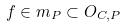Convert formula to latex. <formula><loc_0><loc_0><loc_500><loc_500>f \in m _ { P } \subset O _ { C , P }</formula> 